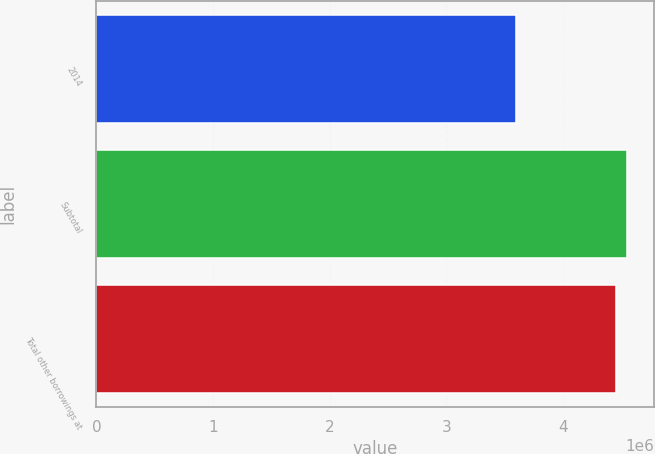<chart> <loc_0><loc_0><loc_500><loc_500><bar_chart><fcel>2014<fcel>Subtotal<fcel>Total other borrowings at<nl><fcel>3.59284e+06<fcel>4.54966e+06<fcel>4.45466e+06<nl></chart> 